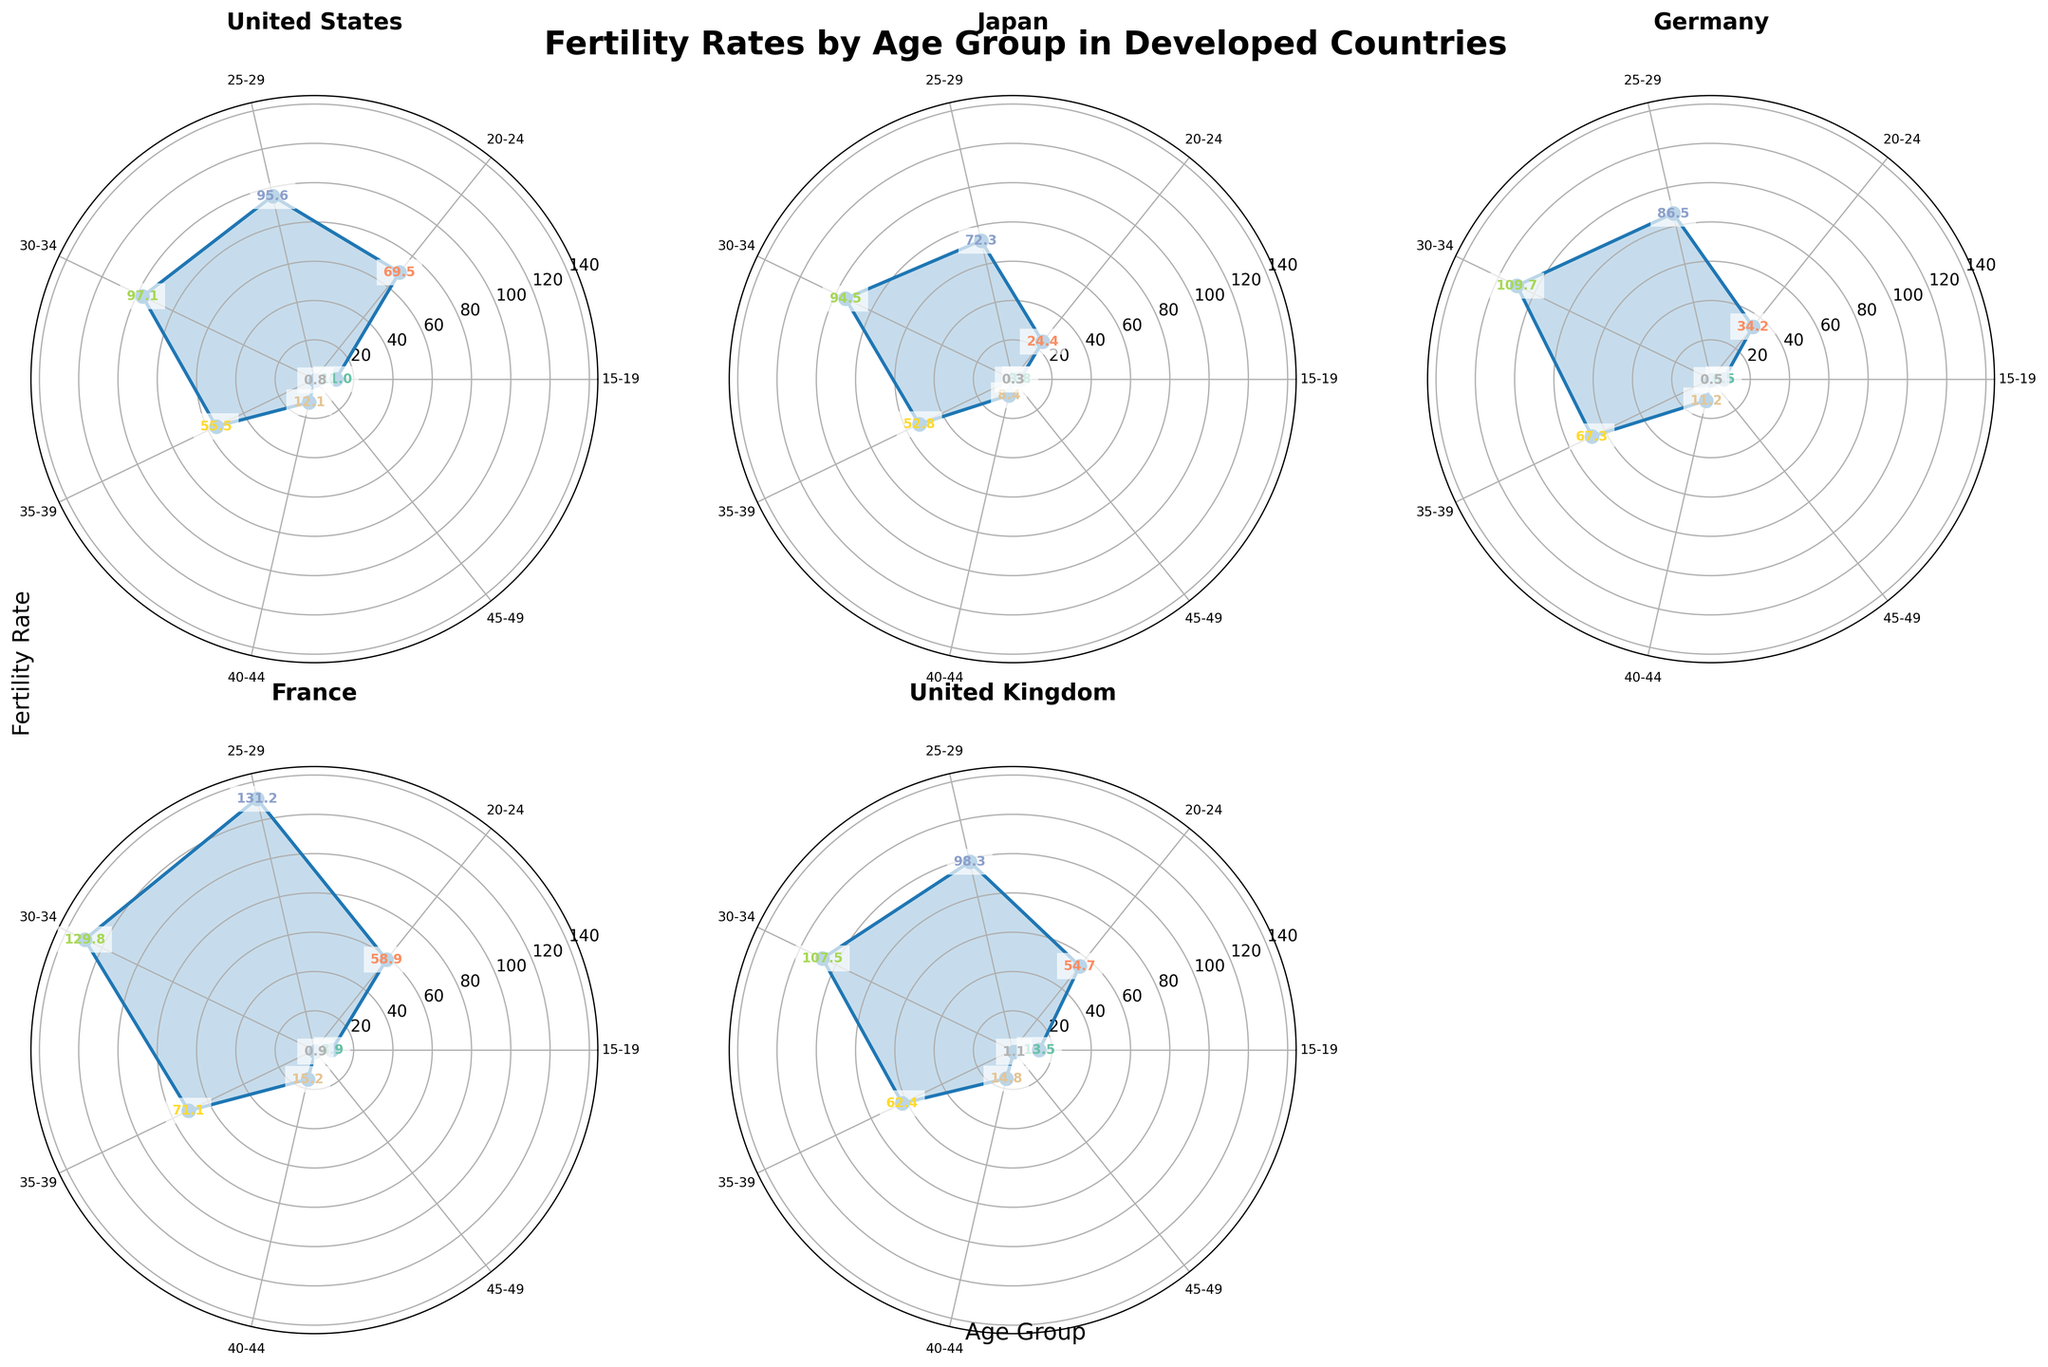How many age groups are represented in the figure? Each subplot of the polar chart represents data for different age groups. By counting the sections on any of the subplots, you can see there are 7 distinct age groups: '15-19', '20-24', '25-29', '30-34', '35-39', '40-44', and '45-49'.
Answer: 7 Which country has the highest fertility rate in the '30-34' age group? Looking at the data points plotted for the '30-34' age group in each subplot of the polar charts, France has the highest value of 129.8.
Answer: France What is the average fertility rate for the '20-24' age group across all countries? The fertility rates for the '20-24' age group are: US (69.5), Japan (24.4), Germany (34.2), France (58.9), and UK (54.7). Summing these values gives 241.7. Dividing by the number of countries (5) gives an average of 48.3.
Answer: 48.3 Does any country have a fertility rate below 1 for the '40-44' age group? By checking the plotted data points for the '40-44' age group in all subplots, we see that all countries have fertility rates above 1 for this age group.
Answer: No How do the fertility rates for '35-39' age group compare between Germany and the United Kingdom? Looking at the specific data points plotted on the subplots for the '35-39' age group, Germany has a rate of 67.3 and the United Kingdom has a rate of 62.4. Thus, Germany's rate is higher than the United Kingdom's.
Answer: Germany's is higher Which country shows the largest variation in fertility rates across all age groups? To determine this, we need to consider the range (difference between the highest and lowest values) in each country's subplot. France shows the largest variation with values ranging from 0.9 to 131.2, making the range 130.3.
Answer: France What is the sum of the fertility rates for the '40-44' age group across all countries? The values for the '40-44' age group are: US (12.1), Japan (8.4), Germany (11.2), France (15.2), and UK (14.8). Summing them gives 61.7.
Answer: 61.7 